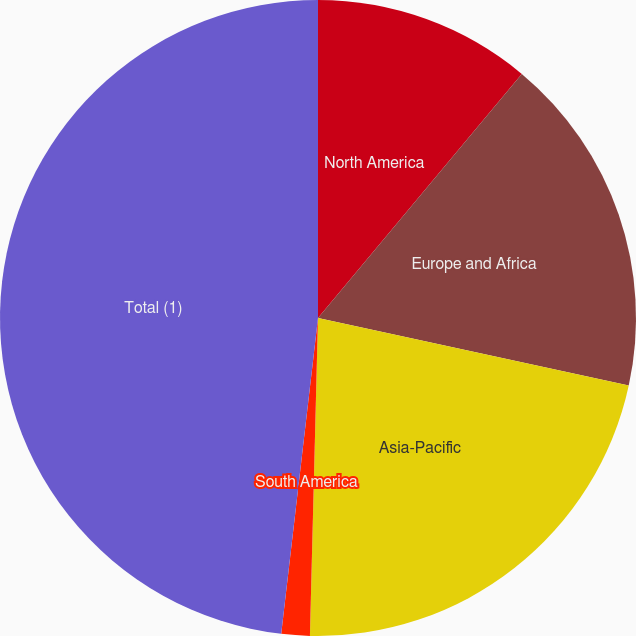Convert chart to OTSL. <chart><loc_0><loc_0><loc_500><loc_500><pie_chart><fcel>North America<fcel>Europe and Africa<fcel>Asia-Pacific<fcel>South America<fcel>Total (1)<nl><fcel>11.07%<fcel>17.33%<fcel>22.0%<fcel>1.44%<fcel>48.15%<nl></chart> 